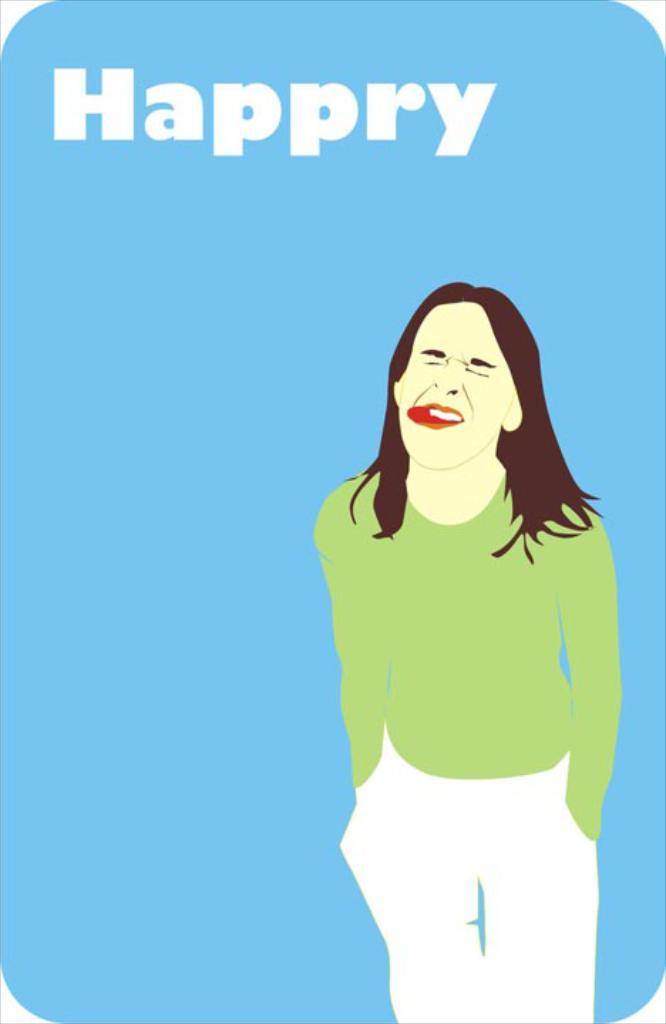<image>
Offer a succinct explanation of the picture presented. the word happry is on the blue object 